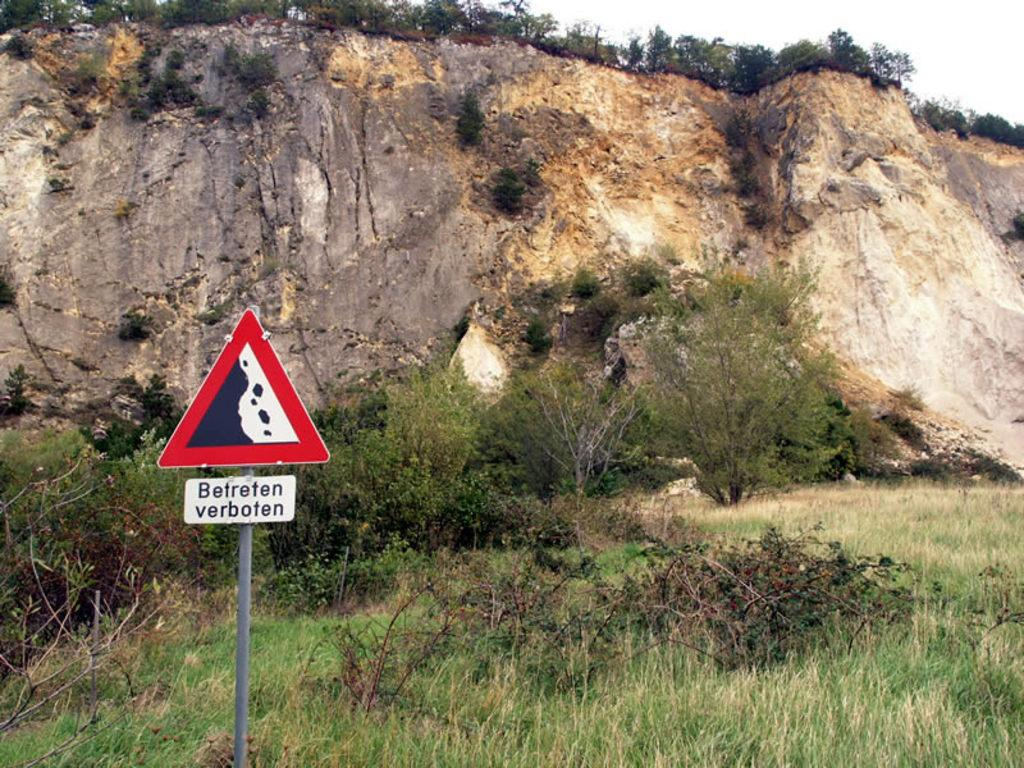<image>
Relay a brief, clear account of the picture shown. A red triangular sign reads "Betreten verbote" in front of a cliff. 